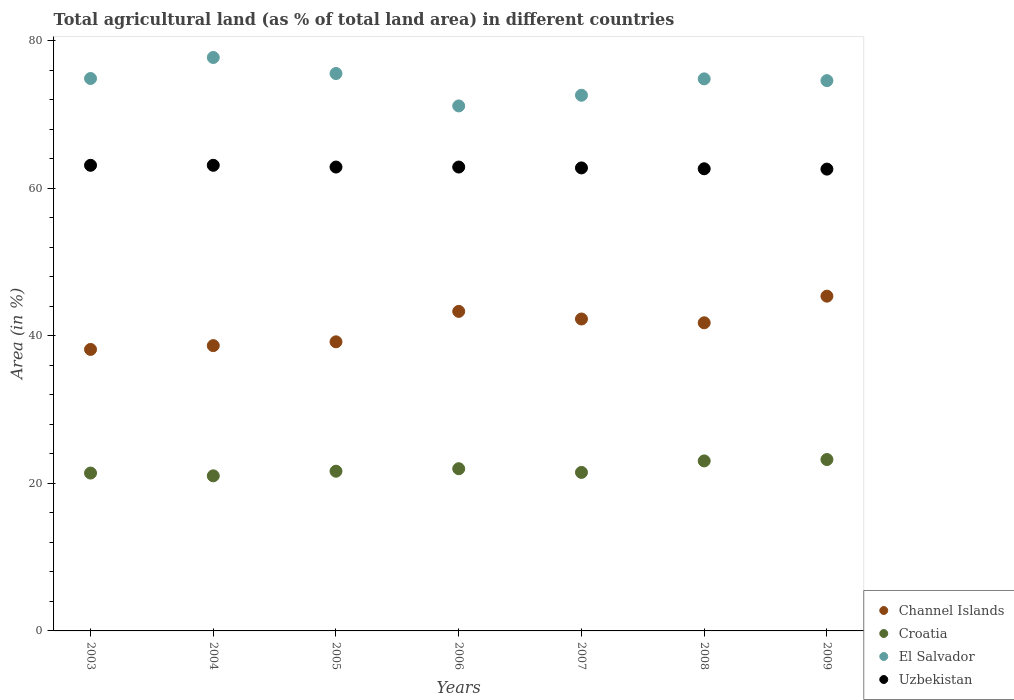How many different coloured dotlines are there?
Provide a short and direct response. 4. What is the percentage of agricultural land in Channel Islands in 2007?
Keep it short and to the point. 42.27. Across all years, what is the maximum percentage of agricultural land in El Salvador?
Your response must be concise. 77.7. Across all years, what is the minimum percentage of agricultural land in El Salvador?
Make the answer very short. 71.14. In which year was the percentage of agricultural land in Uzbekistan minimum?
Provide a short and direct response. 2009. What is the total percentage of agricultural land in Uzbekistan in the graph?
Give a very brief answer. 439.84. What is the difference between the percentage of agricultural land in Channel Islands in 2003 and that in 2006?
Provide a short and direct response. -5.15. What is the difference between the percentage of agricultural land in El Salvador in 2005 and the percentage of agricultural land in Croatia in 2007?
Your answer should be very brief. 54.05. What is the average percentage of agricultural land in Uzbekistan per year?
Give a very brief answer. 62.83. In the year 2005, what is the difference between the percentage of agricultural land in Croatia and percentage of agricultural land in Channel Islands?
Your answer should be compact. -17.53. What is the ratio of the percentage of agricultural land in Croatia in 2008 to that in 2009?
Ensure brevity in your answer.  0.99. Is the percentage of agricultural land in Croatia in 2005 less than that in 2009?
Your response must be concise. Yes. Is the difference between the percentage of agricultural land in Croatia in 2003 and 2008 greater than the difference between the percentage of agricultural land in Channel Islands in 2003 and 2008?
Offer a terse response. Yes. What is the difference between the highest and the second highest percentage of agricultural land in El Salvador?
Offer a terse response. 2.17. What is the difference between the highest and the lowest percentage of agricultural land in Uzbekistan?
Give a very brief answer. 0.52. Is it the case that in every year, the sum of the percentage of agricultural land in Croatia and percentage of agricultural land in El Salvador  is greater than the sum of percentage of agricultural land in Uzbekistan and percentage of agricultural land in Channel Islands?
Your answer should be very brief. Yes. How many dotlines are there?
Give a very brief answer. 4. How many years are there in the graph?
Keep it short and to the point. 7. What is the difference between two consecutive major ticks on the Y-axis?
Provide a short and direct response. 20. Does the graph contain any zero values?
Offer a very short reply. No. How many legend labels are there?
Ensure brevity in your answer.  4. What is the title of the graph?
Provide a succinct answer. Total agricultural land (as % of total land area) in different countries. What is the label or title of the Y-axis?
Ensure brevity in your answer.  Area (in %). What is the Area (in %) in Channel Islands in 2003?
Your response must be concise. 38.14. What is the Area (in %) of Croatia in 2003?
Keep it short and to the point. 21.39. What is the Area (in %) of El Salvador in 2003?
Offer a terse response. 74.86. What is the Area (in %) in Uzbekistan in 2003?
Give a very brief answer. 63.09. What is the Area (in %) in Channel Islands in 2004?
Your response must be concise. 38.66. What is the Area (in %) of Croatia in 2004?
Provide a short and direct response. 21.02. What is the Area (in %) of El Salvador in 2004?
Your response must be concise. 77.7. What is the Area (in %) in Uzbekistan in 2004?
Provide a succinct answer. 63.09. What is the Area (in %) of Channel Islands in 2005?
Give a very brief answer. 39.18. What is the Area (in %) of Croatia in 2005?
Provide a succinct answer. 21.64. What is the Area (in %) of El Salvador in 2005?
Make the answer very short. 75.53. What is the Area (in %) of Uzbekistan in 2005?
Your answer should be compact. 62.86. What is the Area (in %) of Channel Islands in 2006?
Your answer should be compact. 43.3. What is the Area (in %) of Croatia in 2006?
Your response must be concise. 21.98. What is the Area (in %) in El Salvador in 2006?
Make the answer very short. 71.14. What is the Area (in %) in Uzbekistan in 2006?
Provide a short and direct response. 62.86. What is the Area (in %) of Channel Islands in 2007?
Give a very brief answer. 42.27. What is the Area (in %) of Croatia in 2007?
Your answer should be very brief. 21.48. What is the Area (in %) in El Salvador in 2007?
Offer a terse response. 72.59. What is the Area (in %) of Uzbekistan in 2007?
Offer a terse response. 62.74. What is the Area (in %) in Channel Islands in 2008?
Your response must be concise. 41.75. What is the Area (in %) of Croatia in 2008?
Provide a succinct answer. 23.04. What is the Area (in %) of El Salvador in 2008?
Keep it short and to the point. 74.81. What is the Area (in %) of Uzbekistan in 2008?
Offer a very short reply. 62.62. What is the Area (in %) in Channel Islands in 2009?
Offer a very short reply. 45.36. What is the Area (in %) of Croatia in 2009?
Offer a very short reply. 23.22. What is the Area (in %) of El Salvador in 2009?
Ensure brevity in your answer.  74.57. What is the Area (in %) of Uzbekistan in 2009?
Give a very brief answer. 62.58. Across all years, what is the maximum Area (in %) of Channel Islands?
Your response must be concise. 45.36. Across all years, what is the maximum Area (in %) in Croatia?
Provide a short and direct response. 23.22. Across all years, what is the maximum Area (in %) in El Salvador?
Ensure brevity in your answer.  77.7. Across all years, what is the maximum Area (in %) in Uzbekistan?
Offer a terse response. 63.09. Across all years, what is the minimum Area (in %) of Channel Islands?
Your response must be concise. 38.14. Across all years, what is the minimum Area (in %) of Croatia?
Offer a very short reply. 21.02. Across all years, what is the minimum Area (in %) in El Salvador?
Make the answer very short. 71.14. Across all years, what is the minimum Area (in %) of Uzbekistan?
Provide a short and direct response. 62.58. What is the total Area (in %) of Channel Islands in the graph?
Ensure brevity in your answer.  288.66. What is the total Area (in %) in Croatia in the graph?
Keep it short and to the point. 153.77. What is the total Area (in %) in El Salvador in the graph?
Provide a short and direct response. 521.19. What is the total Area (in %) of Uzbekistan in the graph?
Your answer should be very brief. 439.84. What is the difference between the Area (in %) of Channel Islands in 2003 and that in 2004?
Keep it short and to the point. -0.52. What is the difference between the Area (in %) in Croatia in 2003 and that in 2004?
Ensure brevity in your answer.  0.38. What is the difference between the Area (in %) in El Salvador in 2003 and that in 2004?
Your answer should be compact. -2.85. What is the difference between the Area (in %) of Channel Islands in 2003 and that in 2005?
Keep it short and to the point. -1.03. What is the difference between the Area (in %) in Croatia in 2003 and that in 2005?
Your answer should be very brief. -0.25. What is the difference between the Area (in %) in El Salvador in 2003 and that in 2005?
Ensure brevity in your answer.  -0.68. What is the difference between the Area (in %) in Uzbekistan in 2003 and that in 2005?
Ensure brevity in your answer.  0.24. What is the difference between the Area (in %) of Channel Islands in 2003 and that in 2006?
Make the answer very short. -5.15. What is the difference between the Area (in %) of Croatia in 2003 and that in 2006?
Provide a short and direct response. -0.59. What is the difference between the Area (in %) of El Salvador in 2003 and that in 2006?
Your response must be concise. 3.72. What is the difference between the Area (in %) of Uzbekistan in 2003 and that in 2006?
Provide a succinct answer. 0.24. What is the difference between the Area (in %) of Channel Islands in 2003 and that in 2007?
Your answer should be compact. -4.12. What is the difference between the Area (in %) of Croatia in 2003 and that in 2007?
Offer a terse response. -0.09. What is the difference between the Area (in %) in El Salvador in 2003 and that in 2007?
Your answer should be very brief. 2.27. What is the difference between the Area (in %) of Uzbekistan in 2003 and that in 2007?
Your response must be concise. 0.35. What is the difference between the Area (in %) in Channel Islands in 2003 and that in 2008?
Offer a very short reply. -3.61. What is the difference between the Area (in %) of Croatia in 2003 and that in 2008?
Your response must be concise. -1.64. What is the difference between the Area (in %) in El Salvador in 2003 and that in 2008?
Make the answer very short. 0.05. What is the difference between the Area (in %) of Uzbekistan in 2003 and that in 2008?
Provide a short and direct response. 0.47. What is the difference between the Area (in %) in Channel Islands in 2003 and that in 2009?
Offer a terse response. -7.22. What is the difference between the Area (in %) of Croatia in 2003 and that in 2009?
Provide a succinct answer. -1.83. What is the difference between the Area (in %) in El Salvador in 2003 and that in 2009?
Your answer should be very brief. 0.29. What is the difference between the Area (in %) in Uzbekistan in 2003 and that in 2009?
Provide a short and direct response. 0.52. What is the difference between the Area (in %) of Channel Islands in 2004 and that in 2005?
Keep it short and to the point. -0.52. What is the difference between the Area (in %) of Croatia in 2004 and that in 2005?
Make the answer very short. -0.63. What is the difference between the Area (in %) of El Salvador in 2004 and that in 2005?
Your answer should be compact. 2.17. What is the difference between the Area (in %) in Uzbekistan in 2004 and that in 2005?
Ensure brevity in your answer.  0.24. What is the difference between the Area (in %) of Channel Islands in 2004 and that in 2006?
Ensure brevity in your answer.  -4.64. What is the difference between the Area (in %) of Croatia in 2004 and that in 2006?
Keep it short and to the point. -0.96. What is the difference between the Area (in %) in El Salvador in 2004 and that in 2006?
Your response must be concise. 6.56. What is the difference between the Area (in %) of Uzbekistan in 2004 and that in 2006?
Offer a very short reply. 0.24. What is the difference between the Area (in %) of Channel Islands in 2004 and that in 2007?
Give a very brief answer. -3.61. What is the difference between the Area (in %) of Croatia in 2004 and that in 2007?
Ensure brevity in your answer.  -0.46. What is the difference between the Area (in %) in El Salvador in 2004 and that in 2007?
Your answer should be very brief. 5.12. What is the difference between the Area (in %) in Uzbekistan in 2004 and that in 2007?
Give a very brief answer. 0.35. What is the difference between the Area (in %) in Channel Islands in 2004 and that in 2008?
Your answer should be very brief. -3.09. What is the difference between the Area (in %) of Croatia in 2004 and that in 2008?
Your answer should be compact. -2.02. What is the difference between the Area (in %) in El Salvador in 2004 and that in 2008?
Make the answer very short. 2.9. What is the difference between the Area (in %) in Uzbekistan in 2004 and that in 2008?
Offer a very short reply. 0.47. What is the difference between the Area (in %) of Channel Islands in 2004 and that in 2009?
Make the answer very short. -6.7. What is the difference between the Area (in %) of Croatia in 2004 and that in 2009?
Give a very brief answer. -2.21. What is the difference between the Area (in %) in El Salvador in 2004 and that in 2009?
Offer a very short reply. 3.14. What is the difference between the Area (in %) in Uzbekistan in 2004 and that in 2009?
Offer a terse response. 0.52. What is the difference between the Area (in %) in Channel Islands in 2005 and that in 2006?
Your response must be concise. -4.12. What is the difference between the Area (in %) of Croatia in 2005 and that in 2006?
Give a very brief answer. -0.34. What is the difference between the Area (in %) in El Salvador in 2005 and that in 2006?
Your response must be concise. 4.39. What is the difference between the Area (in %) in Uzbekistan in 2005 and that in 2006?
Offer a terse response. 0. What is the difference between the Area (in %) of Channel Islands in 2005 and that in 2007?
Your response must be concise. -3.09. What is the difference between the Area (in %) of Croatia in 2005 and that in 2007?
Your response must be concise. 0.16. What is the difference between the Area (in %) in El Salvador in 2005 and that in 2007?
Ensure brevity in your answer.  2.94. What is the difference between the Area (in %) of Uzbekistan in 2005 and that in 2007?
Your answer should be very brief. 0.12. What is the difference between the Area (in %) in Channel Islands in 2005 and that in 2008?
Make the answer very short. -2.58. What is the difference between the Area (in %) in Croatia in 2005 and that in 2008?
Provide a short and direct response. -1.4. What is the difference between the Area (in %) in El Salvador in 2005 and that in 2008?
Keep it short and to the point. 0.72. What is the difference between the Area (in %) of Uzbekistan in 2005 and that in 2008?
Keep it short and to the point. 0.24. What is the difference between the Area (in %) in Channel Islands in 2005 and that in 2009?
Provide a short and direct response. -6.19. What is the difference between the Area (in %) of Croatia in 2005 and that in 2009?
Provide a succinct answer. -1.58. What is the difference between the Area (in %) of El Salvador in 2005 and that in 2009?
Your response must be concise. 0.97. What is the difference between the Area (in %) of Uzbekistan in 2005 and that in 2009?
Make the answer very short. 0.28. What is the difference between the Area (in %) in Channel Islands in 2006 and that in 2007?
Offer a terse response. 1.03. What is the difference between the Area (in %) in Croatia in 2006 and that in 2007?
Offer a terse response. 0.5. What is the difference between the Area (in %) of El Salvador in 2006 and that in 2007?
Provide a short and direct response. -1.45. What is the difference between the Area (in %) of Uzbekistan in 2006 and that in 2007?
Offer a terse response. 0.12. What is the difference between the Area (in %) of Channel Islands in 2006 and that in 2008?
Provide a succinct answer. 1.55. What is the difference between the Area (in %) in Croatia in 2006 and that in 2008?
Provide a short and direct response. -1.06. What is the difference between the Area (in %) in El Salvador in 2006 and that in 2008?
Keep it short and to the point. -3.67. What is the difference between the Area (in %) of Uzbekistan in 2006 and that in 2008?
Make the answer very short. 0.24. What is the difference between the Area (in %) of Channel Islands in 2006 and that in 2009?
Your answer should be compact. -2.06. What is the difference between the Area (in %) of Croatia in 2006 and that in 2009?
Your answer should be compact. -1.24. What is the difference between the Area (in %) in El Salvador in 2006 and that in 2009?
Provide a short and direct response. -3.43. What is the difference between the Area (in %) in Uzbekistan in 2006 and that in 2009?
Make the answer very short. 0.28. What is the difference between the Area (in %) in Channel Islands in 2007 and that in 2008?
Your answer should be compact. 0.52. What is the difference between the Area (in %) of Croatia in 2007 and that in 2008?
Your response must be concise. -1.56. What is the difference between the Area (in %) in El Salvador in 2007 and that in 2008?
Ensure brevity in your answer.  -2.22. What is the difference between the Area (in %) of Uzbekistan in 2007 and that in 2008?
Provide a short and direct response. 0.12. What is the difference between the Area (in %) of Channel Islands in 2007 and that in 2009?
Provide a short and direct response. -3.09. What is the difference between the Area (in %) of Croatia in 2007 and that in 2009?
Your answer should be very brief. -1.74. What is the difference between the Area (in %) of El Salvador in 2007 and that in 2009?
Your answer should be compact. -1.98. What is the difference between the Area (in %) of Uzbekistan in 2007 and that in 2009?
Your answer should be very brief. 0.16. What is the difference between the Area (in %) in Channel Islands in 2008 and that in 2009?
Give a very brief answer. -3.61. What is the difference between the Area (in %) of Croatia in 2008 and that in 2009?
Your response must be concise. -0.19. What is the difference between the Area (in %) of El Salvador in 2008 and that in 2009?
Provide a succinct answer. 0.24. What is the difference between the Area (in %) of Uzbekistan in 2008 and that in 2009?
Your answer should be compact. 0.05. What is the difference between the Area (in %) of Channel Islands in 2003 and the Area (in %) of Croatia in 2004?
Offer a very short reply. 17.13. What is the difference between the Area (in %) of Channel Islands in 2003 and the Area (in %) of El Salvador in 2004?
Your response must be concise. -39.56. What is the difference between the Area (in %) in Channel Islands in 2003 and the Area (in %) in Uzbekistan in 2004?
Give a very brief answer. -24.95. What is the difference between the Area (in %) of Croatia in 2003 and the Area (in %) of El Salvador in 2004?
Provide a short and direct response. -56.31. What is the difference between the Area (in %) of Croatia in 2003 and the Area (in %) of Uzbekistan in 2004?
Your answer should be compact. -41.7. What is the difference between the Area (in %) in El Salvador in 2003 and the Area (in %) in Uzbekistan in 2004?
Your response must be concise. 11.76. What is the difference between the Area (in %) of Channel Islands in 2003 and the Area (in %) of Croatia in 2005?
Provide a succinct answer. 16.5. What is the difference between the Area (in %) of Channel Islands in 2003 and the Area (in %) of El Salvador in 2005?
Your answer should be very brief. -37.39. What is the difference between the Area (in %) of Channel Islands in 2003 and the Area (in %) of Uzbekistan in 2005?
Your response must be concise. -24.71. What is the difference between the Area (in %) in Croatia in 2003 and the Area (in %) in El Salvador in 2005?
Ensure brevity in your answer.  -54.14. What is the difference between the Area (in %) in Croatia in 2003 and the Area (in %) in Uzbekistan in 2005?
Keep it short and to the point. -41.47. What is the difference between the Area (in %) of El Salvador in 2003 and the Area (in %) of Uzbekistan in 2005?
Your response must be concise. 12. What is the difference between the Area (in %) of Channel Islands in 2003 and the Area (in %) of Croatia in 2006?
Offer a very short reply. 16.16. What is the difference between the Area (in %) of Channel Islands in 2003 and the Area (in %) of El Salvador in 2006?
Provide a succinct answer. -32.99. What is the difference between the Area (in %) in Channel Islands in 2003 and the Area (in %) in Uzbekistan in 2006?
Your response must be concise. -24.71. What is the difference between the Area (in %) of Croatia in 2003 and the Area (in %) of El Salvador in 2006?
Your answer should be compact. -49.75. What is the difference between the Area (in %) in Croatia in 2003 and the Area (in %) in Uzbekistan in 2006?
Your answer should be compact. -41.47. What is the difference between the Area (in %) of El Salvador in 2003 and the Area (in %) of Uzbekistan in 2006?
Make the answer very short. 12. What is the difference between the Area (in %) in Channel Islands in 2003 and the Area (in %) in Croatia in 2007?
Make the answer very short. 16.66. What is the difference between the Area (in %) of Channel Islands in 2003 and the Area (in %) of El Salvador in 2007?
Ensure brevity in your answer.  -34.44. What is the difference between the Area (in %) in Channel Islands in 2003 and the Area (in %) in Uzbekistan in 2007?
Ensure brevity in your answer.  -24.6. What is the difference between the Area (in %) of Croatia in 2003 and the Area (in %) of El Salvador in 2007?
Make the answer very short. -51.2. What is the difference between the Area (in %) of Croatia in 2003 and the Area (in %) of Uzbekistan in 2007?
Offer a terse response. -41.35. What is the difference between the Area (in %) in El Salvador in 2003 and the Area (in %) in Uzbekistan in 2007?
Give a very brief answer. 12.11. What is the difference between the Area (in %) of Channel Islands in 2003 and the Area (in %) of Croatia in 2008?
Keep it short and to the point. 15.11. What is the difference between the Area (in %) of Channel Islands in 2003 and the Area (in %) of El Salvador in 2008?
Provide a succinct answer. -36.66. What is the difference between the Area (in %) of Channel Islands in 2003 and the Area (in %) of Uzbekistan in 2008?
Keep it short and to the point. -24.48. What is the difference between the Area (in %) of Croatia in 2003 and the Area (in %) of El Salvador in 2008?
Keep it short and to the point. -53.42. What is the difference between the Area (in %) of Croatia in 2003 and the Area (in %) of Uzbekistan in 2008?
Your response must be concise. -41.23. What is the difference between the Area (in %) in El Salvador in 2003 and the Area (in %) in Uzbekistan in 2008?
Offer a terse response. 12.23. What is the difference between the Area (in %) of Channel Islands in 2003 and the Area (in %) of Croatia in 2009?
Your answer should be compact. 14.92. What is the difference between the Area (in %) in Channel Islands in 2003 and the Area (in %) in El Salvador in 2009?
Give a very brief answer. -36.42. What is the difference between the Area (in %) in Channel Islands in 2003 and the Area (in %) in Uzbekistan in 2009?
Offer a very short reply. -24.43. What is the difference between the Area (in %) in Croatia in 2003 and the Area (in %) in El Salvador in 2009?
Keep it short and to the point. -53.17. What is the difference between the Area (in %) in Croatia in 2003 and the Area (in %) in Uzbekistan in 2009?
Ensure brevity in your answer.  -41.18. What is the difference between the Area (in %) in El Salvador in 2003 and the Area (in %) in Uzbekistan in 2009?
Ensure brevity in your answer.  12.28. What is the difference between the Area (in %) of Channel Islands in 2004 and the Area (in %) of Croatia in 2005?
Offer a terse response. 17.02. What is the difference between the Area (in %) of Channel Islands in 2004 and the Area (in %) of El Salvador in 2005?
Give a very brief answer. -36.87. What is the difference between the Area (in %) of Channel Islands in 2004 and the Area (in %) of Uzbekistan in 2005?
Offer a terse response. -24.2. What is the difference between the Area (in %) of Croatia in 2004 and the Area (in %) of El Salvador in 2005?
Your answer should be compact. -54.52. What is the difference between the Area (in %) in Croatia in 2004 and the Area (in %) in Uzbekistan in 2005?
Your answer should be compact. -41.84. What is the difference between the Area (in %) of El Salvador in 2004 and the Area (in %) of Uzbekistan in 2005?
Your response must be concise. 14.84. What is the difference between the Area (in %) in Channel Islands in 2004 and the Area (in %) in Croatia in 2006?
Provide a succinct answer. 16.68. What is the difference between the Area (in %) in Channel Islands in 2004 and the Area (in %) in El Salvador in 2006?
Offer a very short reply. -32.48. What is the difference between the Area (in %) of Channel Islands in 2004 and the Area (in %) of Uzbekistan in 2006?
Your answer should be compact. -24.2. What is the difference between the Area (in %) of Croatia in 2004 and the Area (in %) of El Salvador in 2006?
Your answer should be very brief. -50.12. What is the difference between the Area (in %) in Croatia in 2004 and the Area (in %) in Uzbekistan in 2006?
Offer a terse response. -41.84. What is the difference between the Area (in %) in El Salvador in 2004 and the Area (in %) in Uzbekistan in 2006?
Your answer should be compact. 14.84. What is the difference between the Area (in %) in Channel Islands in 2004 and the Area (in %) in Croatia in 2007?
Provide a short and direct response. 17.18. What is the difference between the Area (in %) in Channel Islands in 2004 and the Area (in %) in El Salvador in 2007?
Your answer should be compact. -33.93. What is the difference between the Area (in %) in Channel Islands in 2004 and the Area (in %) in Uzbekistan in 2007?
Offer a terse response. -24.08. What is the difference between the Area (in %) of Croatia in 2004 and the Area (in %) of El Salvador in 2007?
Your response must be concise. -51.57. What is the difference between the Area (in %) of Croatia in 2004 and the Area (in %) of Uzbekistan in 2007?
Ensure brevity in your answer.  -41.73. What is the difference between the Area (in %) in El Salvador in 2004 and the Area (in %) in Uzbekistan in 2007?
Provide a short and direct response. 14.96. What is the difference between the Area (in %) in Channel Islands in 2004 and the Area (in %) in Croatia in 2008?
Keep it short and to the point. 15.62. What is the difference between the Area (in %) of Channel Islands in 2004 and the Area (in %) of El Salvador in 2008?
Make the answer very short. -36.15. What is the difference between the Area (in %) in Channel Islands in 2004 and the Area (in %) in Uzbekistan in 2008?
Give a very brief answer. -23.96. What is the difference between the Area (in %) of Croatia in 2004 and the Area (in %) of El Salvador in 2008?
Your response must be concise. -53.79. What is the difference between the Area (in %) in Croatia in 2004 and the Area (in %) in Uzbekistan in 2008?
Offer a very short reply. -41.61. What is the difference between the Area (in %) in El Salvador in 2004 and the Area (in %) in Uzbekistan in 2008?
Provide a succinct answer. 15.08. What is the difference between the Area (in %) of Channel Islands in 2004 and the Area (in %) of Croatia in 2009?
Offer a very short reply. 15.44. What is the difference between the Area (in %) in Channel Islands in 2004 and the Area (in %) in El Salvador in 2009?
Keep it short and to the point. -35.91. What is the difference between the Area (in %) in Channel Islands in 2004 and the Area (in %) in Uzbekistan in 2009?
Provide a short and direct response. -23.92. What is the difference between the Area (in %) in Croatia in 2004 and the Area (in %) in El Salvador in 2009?
Your answer should be compact. -53.55. What is the difference between the Area (in %) of Croatia in 2004 and the Area (in %) of Uzbekistan in 2009?
Make the answer very short. -41.56. What is the difference between the Area (in %) of El Salvador in 2004 and the Area (in %) of Uzbekistan in 2009?
Provide a short and direct response. 15.13. What is the difference between the Area (in %) in Channel Islands in 2005 and the Area (in %) in Croatia in 2006?
Your response must be concise. 17.2. What is the difference between the Area (in %) in Channel Islands in 2005 and the Area (in %) in El Salvador in 2006?
Make the answer very short. -31.96. What is the difference between the Area (in %) of Channel Islands in 2005 and the Area (in %) of Uzbekistan in 2006?
Give a very brief answer. -23.68. What is the difference between the Area (in %) in Croatia in 2005 and the Area (in %) in El Salvador in 2006?
Your response must be concise. -49.5. What is the difference between the Area (in %) of Croatia in 2005 and the Area (in %) of Uzbekistan in 2006?
Your answer should be very brief. -41.22. What is the difference between the Area (in %) of El Salvador in 2005 and the Area (in %) of Uzbekistan in 2006?
Offer a terse response. 12.67. What is the difference between the Area (in %) in Channel Islands in 2005 and the Area (in %) in Croatia in 2007?
Offer a terse response. 17.7. What is the difference between the Area (in %) in Channel Islands in 2005 and the Area (in %) in El Salvador in 2007?
Ensure brevity in your answer.  -33.41. What is the difference between the Area (in %) of Channel Islands in 2005 and the Area (in %) of Uzbekistan in 2007?
Your answer should be very brief. -23.57. What is the difference between the Area (in %) in Croatia in 2005 and the Area (in %) in El Salvador in 2007?
Make the answer very short. -50.95. What is the difference between the Area (in %) of Croatia in 2005 and the Area (in %) of Uzbekistan in 2007?
Keep it short and to the point. -41.1. What is the difference between the Area (in %) of El Salvador in 2005 and the Area (in %) of Uzbekistan in 2007?
Offer a terse response. 12.79. What is the difference between the Area (in %) in Channel Islands in 2005 and the Area (in %) in Croatia in 2008?
Your response must be concise. 16.14. What is the difference between the Area (in %) in Channel Islands in 2005 and the Area (in %) in El Salvador in 2008?
Keep it short and to the point. -35.63. What is the difference between the Area (in %) of Channel Islands in 2005 and the Area (in %) of Uzbekistan in 2008?
Offer a very short reply. -23.45. What is the difference between the Area (in %) of Croatia in 2005 and the Area (in %) of El Salvador in 2008?
Keep it short and to the point. -53.17. What is the difference between the Area (in %) in Croatia in 2005 and the Area (in %) in Uzbekistan in 2008?
Make the answer very short. -40.98. What is the difference between the Area (in %) in El Salvador in 2005 and the Area (in %) in Uzbekistan in 2008?
Ensure brevity in your answer.  12.91. What is the difference between the Area (in %) of Channel Islands in 2005 and the Area (in %) of Croatia in 2009?
Your answer should be very brief. 15.95. What is the difference between the Area (in %) of Channel Islands in 2005 and the Area (in %) of El Salvador in 2009?
Ensure brevity in your answer.  -35.39. What is the difference between the Area (in %) in Channel Islands in 2005 and the Area (in %) in Uzbekistan in 2009?
Provide a succinct answer. -23.4. What is the difference between the Area (in %) of Croatia in 2005 and the Area (in %) of El Salvador in 2009?
Your answer should be compact. -52.93. What is the difference between the Area (in %) of Croatia in 2005 and the Area (in %) of Uzbekistan in 2009?
Ensure brevity in your answer.  -40.94. What is the difference between the Area (in %) of El Salvador in 2005 and the Area (in %) of Uzbekistan in 2009?
Offer a terse response. 12.95. What is the difference between the Area (in %) of Channel Islands in 2006 and the Area (in %) of Croatia in 2007?
Provide a succinct answer. 21.82. What is the difference between the Area (in %) in Channel Islands in 2006 and the Area (in %) in El Salvador in 2007?
Give a very brief answer. -29.29. What is the difference between the Area (in %) in Channel Islands in 2006 and the Area (in %) in Uzbekistan in 2007?
Provide a succinct answer. -19.44. What is the difference between the Area (in %) of Croatia in 2006 and the Area (in %) of El Salvador in 2007?
Your answer should be very brief. -50.61. What is the difference between the Area (in %) in Croatia in 2006 and the Area (in %) in Uzbekistan in 2007?
Your answer should be compact. -40.76. What is the difference between the Area (in %) of El Salvador in 2006 and the Area (in %) of Uzbekistan in 2007?
Provide a short and direct response. 8.4. What is the difference between the Area (in %) in Channel Islands in 2006 and the Area (in %) in Croatia in 2008?
Ensure brevity in your answer.  20.26. What is the difference between the Area (in %) in Channel Islands in 2006 and the Area (in %) in El Salvador in 2008?
Provide a succinct answer. -31.51. What is the difference between the Area (in %) in Channel Islands in 2006 and the Area (in %) in Uzbekistan in 2008?
Keep it short and to the point. -19.32. What is the difference between the Area (in %) in Croatia in 2006 and the Area (in %) in El Salvador in 2008?
Your answer should be very brief. -52.83. What is the difference between the Area (in %) of Croatia in 2006 and the Area (in %) of Uzbekistan in 2008?
Offer a terse response. -40.64. What is the difference between the Area (in %) in El Salvador in 2006 and the Area (in %) in Uzbekistan in 2008?
Your response must be concise. 8.52. What is the difference between the Area (in %) in Channel Islands in 2006 and the Area (in %) in Croatia in 2009?
Provide a succinct answer. 20.08. What is the difference between the Area (in %) in Channel Islands in 2006 and the Area (in %) in El Salvador in 2009?
Offer a very short reply. -31.27. What is the difference between the Area (in %) of Channel Islands in 2006 and the Area (in %) of Uzbekistan in 2009?
Provide a succinct answer. -19.28. What is the difference between the Area (in %) of Croatia in 2006 and the Area (in %) of El Salvador in 2009?
Provide a succinct answer. -52.59. What is the difference between the Area (in %) in Croatia in 2006 and the Area (in %) in Uzbekistan in 2009?
Your answer should be very brief. -40.6. What is the difference between the Area (in %) in El Salvador in 2006 and the Area (in %) in Uzbekistan in 2009?
Keep it short and to the point. 8.56. What is the difference between the Area (in %) in Channel Islands in 2007 and the Area (in %) in Croatia in 2008?
Offer a terse response. 19.23. What is the difference between the Area (in %) of Channel Islands in 2007 and the Area (in %) of El Salvador in 2008?
Provide a short and direct response. -32.54. What is the difference between the Area (in %) of Channel Islands in 2007 and the Area (in %) of Uzbekistan in 2008?
Make the answer very short. -20.36. What is the difference between the Area (in %) of Croatia in 2007 and the Area (in %) of El Salvador in 2008?
Make the answer very short. -53.33. What is the difference between the Area (in %) in Croatia in 2007 and the Area (in %) in Uzbekistan in 2008?
Your response must be concise. -41.14. What is the difference between the Area (in %) in El Salvador in 2007 and the Area (in %) in Uzbekistan in 2008?
Offer a terse response. 9.96. What is the difference between the Area (in %) of Channel Islands in 2007 and the Area (in %) of Croatia in 2009?
Offer a terse response. 19.04. What is the difference between the Area (in %) in Channel Islands in 2007 and the Area (in %) in El Salvador in 2009?
Your response must be concise. -32.3. What is the difference between the Area (in %) in Channel Islands in 2007 and the Area (in %) in Uzbekistan in 2009?
Provide a short and direct response. -20.31. What is the difference between the Area (in %) in Croatia in 2007 and the Area (in %) in El Salvador in 2009?
Offer a very short reply. -53.09. What is the difference between the Area (in %) of Croatia in 2007 and the Area (in %) of Uzbekistan in 2009?
Your response must be concise. -41.1. What is the difference between the Area (in %) in El Salvador in 2007 and the Area (in %) in Uzbekistan in 2009?
Make the answer very short. 10.01. What is the difference between the Area (in %) of Channel Islands in 2008 and the Area (in %) of Croatia in 2009?
Provide a succinct answer. 18.53. What is the difference between the Area (in %) of Channel Islands in 2008 and the Area (in %) of El Salvador in 2009?
Keep it short and to the point. -32.81. What is the difference between the Area (in %) of Channel Islands in 2008 and the Area (in %) of Uzbekistan in 2009?
Provide a succinct answer. -20.82. What is the difference between the Area (in %) of Croatia in 2008 and the Area (in %) of El Salvador in 2009?
Provide a short and direct response. -51.53. What is the difference between the Area (in %) in Croatia in 2008 and the Area (in %) in Uzbekistan in 2009?
Offer a terse response. -39.54. What is the difference between the Area (in %) of El Salvador in 2008 and the Area (in %) of Uzbekistan in 2009?
Offer a terse response. 12.23. What is the average Area (in %) of Channel Islands per year?
Provide a short and direct response. 41.24. What is the average Area (in %) of Croatia per year?
Provide a short and direct response. 21.97. What is the average Area (in %) in El Salvador per year?
Keep it short and to the point. 74.46. What is the average Area (in %) in Uzbekistan per year?
Your response must be concise. 62.84. In the year 2003, what is the difference between the Area (in %) in Channel Islands and Area (in %) in Croatia?
Your answer should be very brief. 16.75. In the year 2003, what is the difference between the Area (in %) of Channel Islands and Area (in %) of El Salvador?
Ensure brevity in your answer.  -36.71. In the year 2003, what is the difference between the Area (in %) of Channel Islands and Area (in %) of Uzbekistan?
Give a very brief answer. -24.95. In the year 2003, what is the difference between the Area (in %) in Croatia and Area (in %) in El Salvador?
Your answer should be very brief. -53.46. In the year 2003, what is the difference between the Area (in %) of Croatia and Area (in %) of Uzbekistan?
Make the answer very short. -41.7. In the year 2003, what is the difference between the Area (in %) of El Salvador and Area (in %) of Uzbekistan?
Keep it short and to the point. 11.76. In the year 2004, what is the difference between the Area (in %) of Channel Islands and Area (in %) of Croatia?
Your response must be concise. 17.64. In the year 2004, what is the difference between the Area (in %) of Channel Islands and Area (in %) of El Salvador?
Offer a terse response. -39.04. In the year 2004, what is the difference between the Area (in %) of Channel Islands and Area (in %) of Uzbekistan?
Provide a succinct answer. -24.43. In the year 2004, what is the difference between the Area (in %) in Croatia and Area (in %) in El Salvador?
Give a very brief answer. -56.69. In the year 2004, what is the difference between the Area (in %) of Croatia and Area (in %) of Uzbekistan?
Keep it short and to the point. -42.08. In the year 2004, what is the difference between the Area (in %) in El Salvador and Area (in %) in Uzbekistan?
Make the answer very short. 14.61. In the year 2005, what is the difference between the Area (in %) in Channel Islands and Area (in %) in Croatia?
Ensure brevity in your answer.  17.53. In the year 2005, what is the difference between the Area (in %) in Channel Islands and Area (in %) in El Salvador?
Keep it short and to the point. -36.36. In the year 2005, what is the difference between the Area (in %) of Channel Islands and Area (in %) of Uzbekistan?
Offer a very short reply. -23.68. In the year 2005, what is the difference between the Area (in %) of Croatia and Area (in %) of El Salvador?
Your answer should be compact. -53.89. In the year 2005, what is the difference between the Area (in %) of Croatia and Area (in %) of Uzbekistan?
Provide a short and direct response. -41.22. In the year 2005, what is the difference between the Area (in %) in El Salvador and Area (in %) in Uzbekistan?
Provide a succinct answer. 12.67. In the year 2006, what is the difference between the Area (in %) of Channel Islands and Area (in %) of Croatia?
Provide a succinct answer. 21.32. In the year 2006, what is the difference between the Area (in %) in Channel Islands and Area (in %) in El Salvador?
Make the answer very short. -27.84. In the year 2006, what is the difference between the Area (in %) of Channel Islands and Area (in %) of Uzbekistan?
Provide a short and direct response. -19.56. In the year 2006, what is the difference between the Area (in %) of Croatia and Area (in %) of El Salvador?
Keep it short and to the point. -49.16. In the year 2006, what is the difference between the Area (in %) in Croatia and Area (in %) in Uzbekistan?
Offer a terse response. -40.88. In the year 2006, what is the difference between the Area (in %) of El Salvador and Area (in %) of Uzbekistan?
Provide a succinct answer. 8.28. In the year 2007, what is the difference between the Area (in %) in Channel Islands and Area (in %) in Croatia?
Make the answer very short. 20.79. In the year 2007, what is the difference between the Area (in %) in Channel Islands and Area (in %) in El Salvador?
Give a very brief answer. -30.32. In the year 2007, what is the difference between the Area (in %) in Channel Islands and Area (in %) in Uzbekistan?
Keep it short and to the point. -20.47. In the year 2007, what is the difference between the Area (in %) in Croatia and Area (in %) in El Salvador?
Your answer should be very brief. -51.11. In the year 2007, what is the difference between the Area (in %) in Croatia and Area (in %) in Uzbekistan?
Offer a terse response. -41.26. In the year 2007, what is the difference between the Area (in %) in El Salvador and Area (in %) in Uzbekistan?
Provide a short and direct response. 9.85. In the year 2008, what is the difference between the Area (in %) in Channel Islands and Area (in %) in Croatia?
Make the answer very short. 18.72. In the year 2008, what is the difference between the Area (in %) of Channel Islands and Area (in %) of El Salvador?
Give a very brief answer. -33.05. In the year 2008, what is the difference between the Area (in %) in Channel Islands and Area (in %) in Uzbekistan?
Offer a terse response. -20.87. In the year 2008, what is the difference between the Area (in %) in Croatia and Area (in %) in El Salvador?
Offer a terse response. -51.77. In the year 2008, what is the difference between the Area (in %) of Croatia and Area (in %) of Uzbekistan?
Offer a terse response. -39.59. In the year 2008, what is the difference between the Area (in %) of El Salvador and Area (in %) of Uzbekistan?
Ensure brevity in your answer.  12.18. In the year 2009, what is the difference between the Area (in %) of Channel Islands and Area (in %) of Croatia?
Offer a very short reply. 22.14. In the year 2009, what is the difference between the Area (in %) of Channel Islands and Area (in %) of El Salvador?
Keep it short and to the point. -29.2. In the year 2009, what is the difference between the Area (in %) in Channel Islands and Area (in %) in Uzbekistan?
Keep it short and to the point. -17.22. In the year 2009, what is the difference between the Area (in %) of Croatia and Area (in %) of El Salvador?
Your answer should be very brief. -51.34. In the year 2009, what is the difference between the Area (in %) of Croatia and Area (in %) of Uzbekistan?
Your answer should be compact. -39.35. In the year 2009, what is the difference between the Area (in %) of El Salvador and Area (in %) of Uzbekistan?
Your response must be concise. 11.99. What is the ratio of the Area (in %) in Channel Islands in 2003 to that in 2004?
Ensure brevity in your answer.  0.99. What is the ratio of the Area (in %) in Croatia in 2003 to that in 2004?
Offer a very short reply. 1.02. What is the ratio of the Area (in %) of El Salvador in 2003 to that in 2004?
Give a very brief answer. 0.96. What is the ratio of the Area (in %) in Uzbekistan in 2003 to that in 2004?
Provide a short and direct response. 1. What is the ratio of the Area (in %) of Channel Islands in 2003 to that in 2005?
Ensure brevity in your answer.  0.97. What is the ratio of the Area (in %) in Channel Islands in 2003 to that in 2006?
Your answer should be very brief. 0.88. What is the ratio of the Area (in %) in Croatia in 2003 to that in 2006?
Your answer should be very brief. 0.97. What is the ratio of the Area (in %) in El Salvador in 2003 to that in 2006?
Your response must be concise. 1.05. What is the ratio of the Area (in %) in Channel Islands in 2003 to that in 2007?
Your answer should be very brief. 0.9. What is the ratio of the Area (in %) of El Salvador in 2003 to that in 2007?
Keep it short and to the point. 1.03. What is the ratio of the Area (in %) of Uzbekistan in 2003 to that in 2007?
Provide a succinct answer. 1.01. What is the ratio of the Area (in %) of Channel Islands in 2003 to that in 2008?
Your response must be concise. 0.91. What is the ratio of the Area (in %) of Uzbekistan in 2003 to that in 2008?
Your answer should be very brief. 1.01. What is the ratio of the Area (in %) in Channel Islands in 2003 to that in 2009?
Your response must be concise. 0.84. What is the ratio of the Area (in %) in Croatia in 2003 to that in 2009?
Your response must be concise. 0.92. What is the ratio of the Area (in %) of El Salvador in 2003 to that in 2009?
Your answer should be very brief. 1. What is the ratio of the Area (in %) of Uzbekistan in 2003 to that in 2009?
Provide a short and direct response. 1.01. What is the ratio of the Area (in %) of Croatia in 2004 to that in 2005?
Ensure brevity in your answer.  0.97. What is the ratio of the Area (in %) in El Salvador in 2004 to that in 2005?
Your answer should be compact. 1.03. What is the ratio of the Area (in %) of Uzbekistan in 2004 to that in 2005?
Offer a very short reply. 1. What is the ratio of the Area (in %) in Channel Islands in 2004 to that in 2006?
Your answer should be very brief. 0.89. What is the ratio of the Area (in %) of Croatia in 2004 to that in 2006?
Provide a short and direct response. 0.96. What is the ratio of the Area (in %) of El Salvador in 2004 to that in 2006?
Make the answer very short. 1.09. What is the ratio of the Area (in %) of Channel Islands in 2004 to that in 2007?
Your answer should be compact. 0.91. What is the ratio of the Area (in %) in Croatia in 2004 to that in 2007?
Your answer should be very brief. 0.98. What is the ratio of the Area (in %) in El Salvador in 2004 to that in 2007?
Offer a terse response. 1.07. What is the ratio of the Area (in %) of Uzbekistan in 2004 to that in 2007?
Your answer should be compact. 1.01. What is the ratio of the Area (in %) in Channel Islands in 2004 to that in 2008?
Provide a succinct answer. 0.93. What is the ratio of the Area (in %) in Croatia in 2004 to that in 2008?
Give a very brief answer. 0.91. What is the ratio of the Area (in %) in El Salvador in 2004 to that in 2008?
Your response must be concise. 1.04. What is the ratio of the Area (in %) in Uzbekistan in 2004 to that in 2008?
Provide a succinct answer. 1.01. What is the ratio of the Area (in %) of Channel Islands in 2004 to that in 2009?
Provide a succinct answer. 0.85. What is the ratio of the Area (in %) of Croatia in 2004 to that in 2009?
Give a very brief answer. 0.9. What is the ratio of the Area (in %) of El Salvador in 2004 to that in 2009?
Offer a terse response. 1.04. What is the ratio of the Area (in %) in Uzbekistan in 2004 to that in 2009?
Offer a very short reply. 1.01. What is the ratio of the Area (in %) in Channel Islands in 2005 to that in 2006?
Your response must be concise. 0.9. What is the ratio of the Area (in %) in Croatia in 2005 to that in 2006?
Offer a very short reply. 0.98. What is the ratio of the Area (in %) of El Salvador in 2005 to that in 2006?
Offer a terse response. 1.06. What is the ratio of the Area (in %) in Uzbekistan in 2005 to that in 2006?
Your answer should be compact. 1. What is the ratio of the Area (in %) in Channel Islands in 2005 to that in 2007?
Your answer should be very brief. 0.93. What is the ratio of the Area (in %) in Croatia in 2005 to that in 2007?
Offer a terse response. 1.01. What is the ratio of the Area (in %) of El Salvador in 2005 to that in 2007?
Provide a succinct answer. 1.04. What is the ratio of the Area (in %) in Uzbekistan in 2005 to that in 2007?
Offer a very short reply. 1. What is the ratio of the Area (in %) in Channel Islands in 2005 to that in 2008?
Your answer should be compact. 0.94. What is the ratio of the Area (in %) of Croatia in 2005 to that in 2008?
Give a very brief answer. 0.94. What is the ratio of the Area (in %) of El Salvador in 2005 to that in 2008?
Make the answer very short. 1.01. What is the ratio of the Area (in %) in Uzbekistan in 2005 to that in 2008?
Your response must be concise. 1. What is the ratio of the Area (in %) of Channel Islands in 2005 to that in 2009?
Your answer should be compact. 0.86. What is the ratio of the Area (in %) of Croatia in 2005 to that in 2009?
Provide a short and direct response. 0.93. What is the ratio of the Area (in %) of El Salvador in 2005 to that in 2009?
Provide a succinct answer. 1.01. What is the ratio of the Area (in %) in Uzbekistan in 2005 to that in 2009?
Offer a very short reply. 1. What is the ratio of the Area (in %) in Channel Islands in 2006 to that in 2007?
Provide a short and direct response. 1.02. What is the ratio of the Area (in %) in Croatia in 2006 to that in 2007?
Your answer should be very brief. 1.02. What is the ratio of the Area (in %) in El Salvador in 2006 to that in 2007?
Offer a very short reply. 0.98. What is the ratio of the Area (in %) in Uzbekistan in 2006 to that in 2007?
Offer a terse response. 1. What is the ratio of the Area (in %) in Croatia in 2006 to that in 2008?
Make the answer very short. 0.95. What is the ratio of the Area (in %) of El Salvador in 2006 to that in 2008?
Keep it short and to the point. 0.95. What is the ratio of the Area (in %) in Channel Islands in 2006 to that in 2009?
Make the answer very short. 0.95. What is the ratio of the Area (in %) of Croatia in 2006 to that in 2009?
Provide a succinct answer. 0.95. What is the ratio of the Area (in %) of El Salvador in 2006 to that in 2009?
Offer a very short reply. 0.95. What is the ratio of the Area (in %) in Uzbekistan in 2006 to that in 2009?
Give a very brief answer. 1. What is the ratio of the Area (in %) of Channel Islands in 2007 to that in 2008?
Your answer should be very brief. 1.01. What is the ratio of the Area (in %) in Croatia in 2007 to that in 2008?
Your response must be concise. 0.93. What is the ratio of the Area (in %) in El Salvador in 2007 to that in 2008?
Your response must be concise. 0.97. What is the ratio of the Area (in %) in Channel Islands in 2007 to that in 2009?
Keep it short and to the point. 0.93. What is the ratio of the Area (in %) of Croatia in 2007 to that in 2009?
Keep it short and to the point. 0.92. What is the ratio of the Area (in %) of El Salvador in 2007 to that in 2009?
Your response must be concise. 0.97. What is the ratio of the Area (in %) of Uzbekistan in 2007 to that in 2009?
Your response must be concise. 1. What is the ratio of the Area (in %) in Channel Islands in 2008 to that in 2009?
Provide a short and direct response. 0.92. What is the ratio of the Area (in %) of Croatia in 2008 to that in 2009?
Your answer should be compact. 0.99. What is the ratio of the Area (in %) of El Salvador in 2008 to that in 2009?
Offer a very short reply. 1. What is the ratio of the Area (in %) in Uzbekistan in 2008 to that in 2009?
Keep it short and to the point. 1. What is the difference between the highest and the second highest Area (in %) in Channel Islands?
Your answer should be very brief. 2.06. What is the difference between the highest and the second highest Area (in %) in Croatia?
Ensure brevity in your answer.  0.19. What is the difference between the highest and the second highest Area (in %) in El Salvador?
Offer a terse response. 2.17. What is the difference between the highest and the second highest Area (in %) of Uzbekistan?
Your answer should be compact. 0. What is the difference between the highest and the lowest Area (in %) in Channel Islands?
Keep it short and to the point. 7.22. What is the difference between the highest and the lowest Area (in %) of Croatia?
Make the answer very short. 2.21. What is the difference between the highest and the lowest Area (in %) of El Salvador?
Keep it short and to the point. 6.56. What is the difference between the highest and the lowest Area (in %) in Uzbekistan?
Provide a succinct answer. 0.52. 